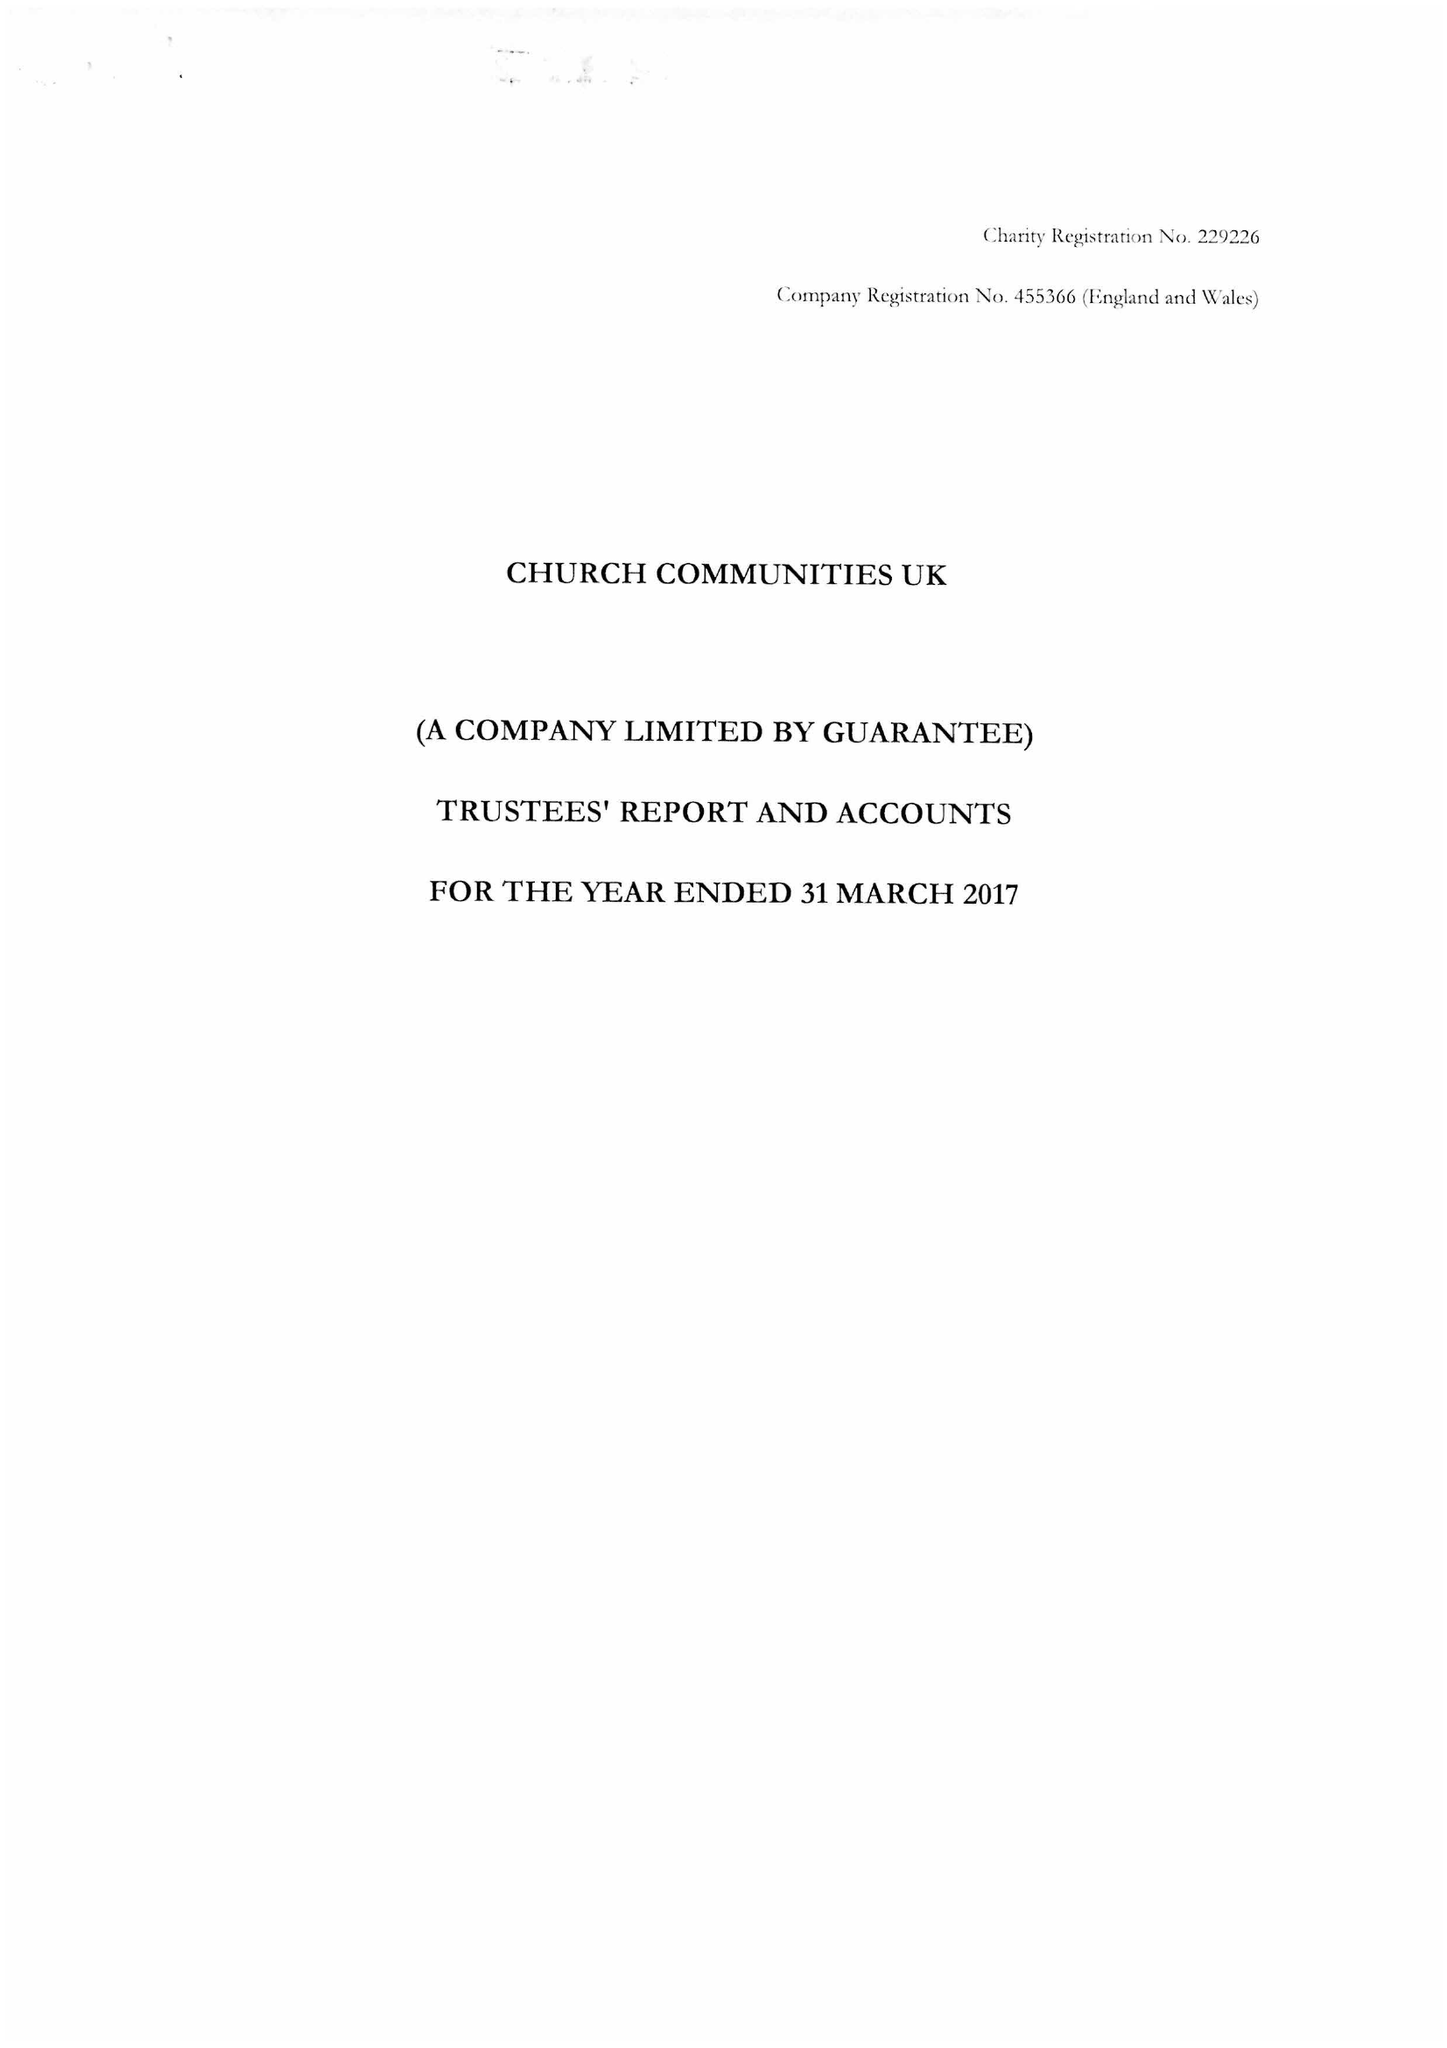What is the value for the address__postcode?
Answer the question using a single word or phrase. TN32 5DR 